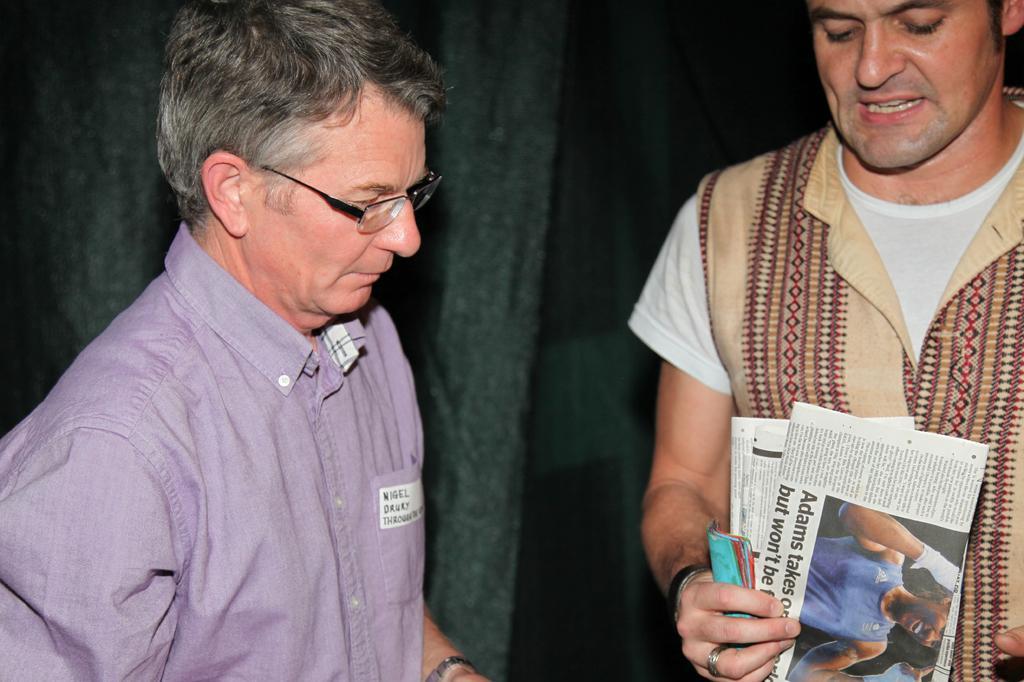Can you describe this image briefly? In this picture we can see two men are standing, a man on the right side is holding some papers, a man on the left side wore spectacles. 